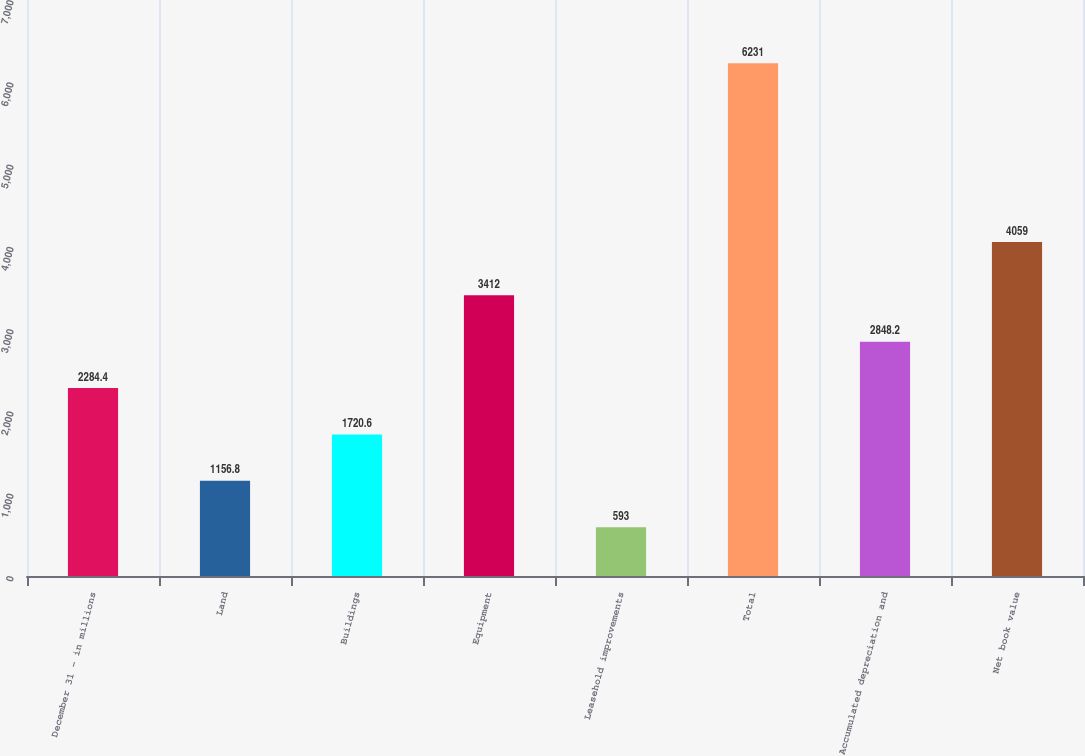Convert chart. <chart><loc_0><loc_0><loc_500><loc_500><bar_chart><fcel>December 31 - in millions<fcel>Land<fcel>Buildings<fcel>Equipment<fcel>Leasehold improvements<fcel>Total<fcel>Accumulated depreciation and<fcel>Net book value<nl><fcel>2284.4<fcel>1156.8<fcel>1720.6<fcel>3412<fcel>593<fcel>6231<fcel>2848.2<fcel>4059<nl></chart> 